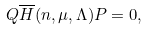<formula> <loc_0><loc_0><loc_500><loc_500>Q \overline { H } ( n , \mu , \Lambda ) P = 0 ,</formula> 